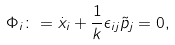Convert formula to latex. <formula><loc_0><loc_0><loc_500><loc_500>\Phi _ { i } \colon = \dot { x } _ { i } + \frac { 1 } { k } \epsilon _ { i j } \tilde { p } _ { j } = 0 ,</formula> 